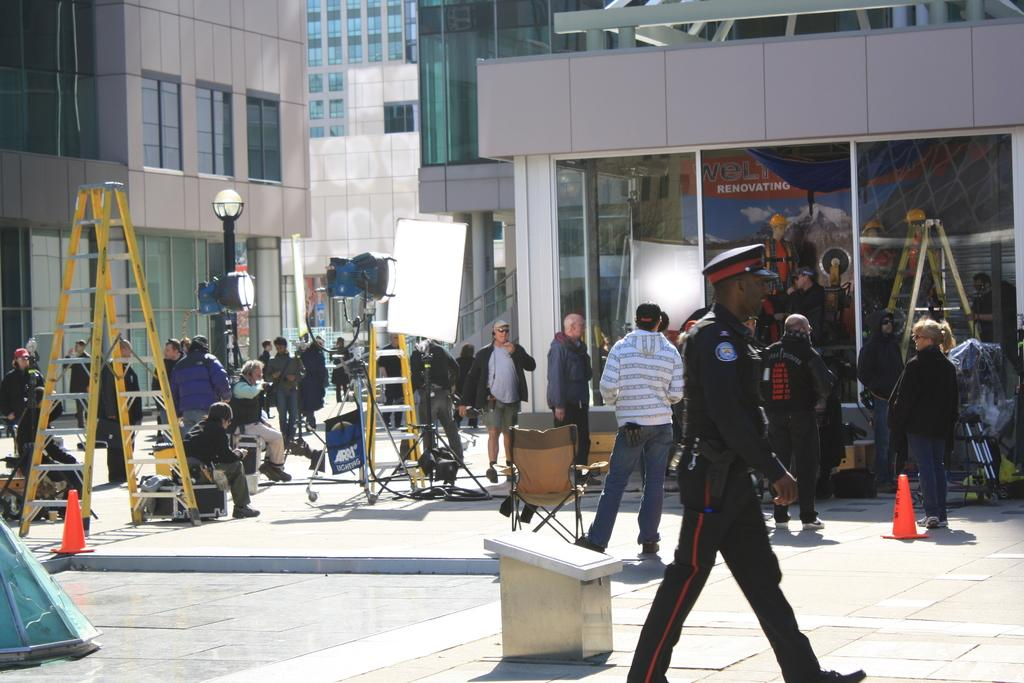What can be seen on the roads in the image? There are people on the roads in the image. What type of structures are visible in the image? There are buildings visible in the image. What crime is being committed by the people on the roads in the image? There is no indication of any crime being committed in the image; it simply shows people on the roads and buildings in the background. How many dimes can be seen on the roads in the image? There are no dimes visible on the roads in the image. 